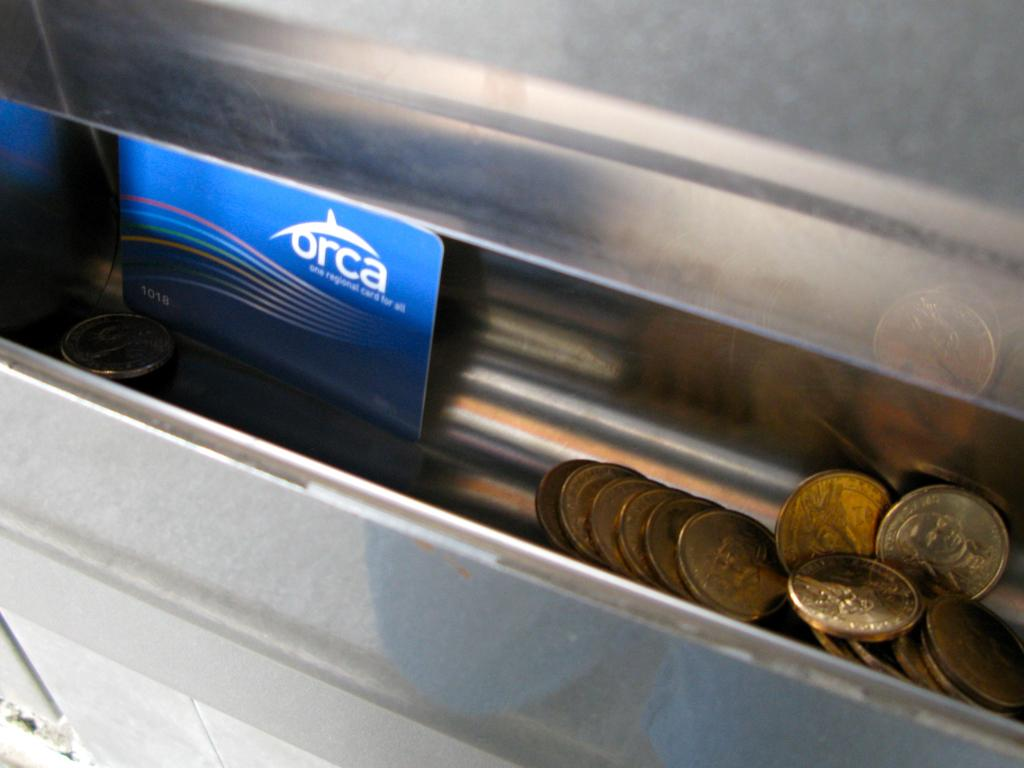What type of objects can be seen in the image? There are coins, a card, and a metal object in the image. Can you describe the card in the image? Unfortunately, the description of the card is not provided in the facts. What is the metal object in the image? The facts only mention that there is a metal object in the image, but its specific nature is not described. What type of grass can be seen growing around the loaf in the image? There is no grass or loaf present in the image; it only contains coins, a card, and a metal object. 